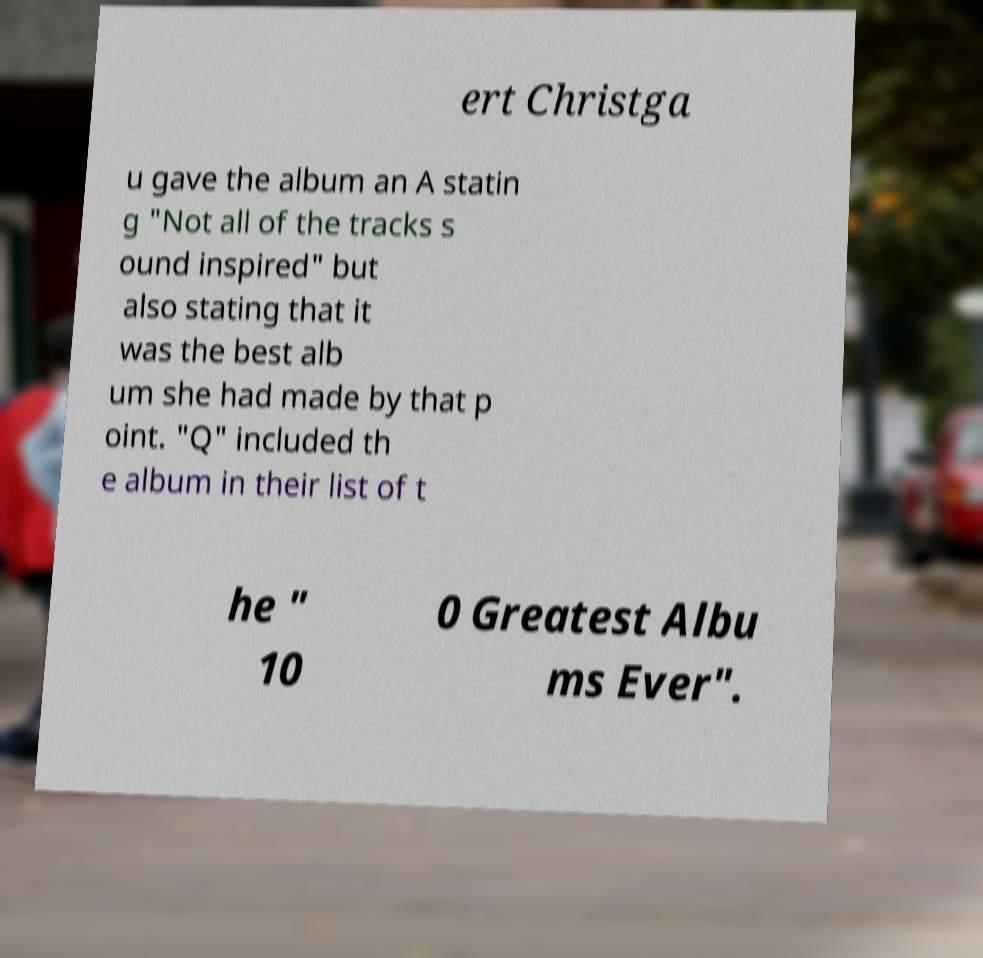Can you accurately transcribe the text from the provided image for me? ert Christga u gave the album an A statin g "Not all of the tracks s ound inspired" but also stating that it was the best alb um she had made by that p oint. "Q" included th e album in their list of t he " 10 0 Greatest Albu ms Ever". 